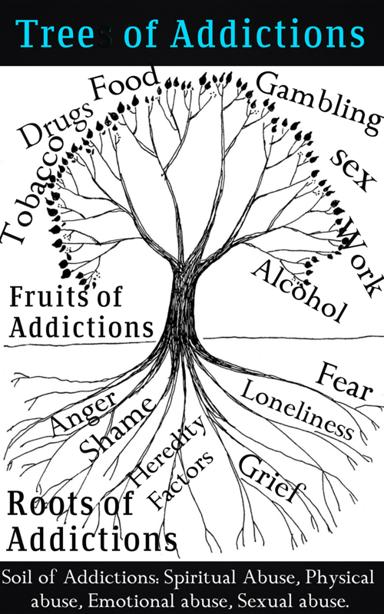What is the purpose of showing the Tree of Addictions in this way? The Tree of Addictions image serves as a compelling metaphorical visualization aimed at illustrating the multifaceted nature of addiction. The intent is to communicate that addictions are not isolated behaviors but are interwoven with emotional consequences (the fruits), have deeper psychological or genetic origins (the roots), and are often fostered by damaging environments or traumatic experiences (the soil). This tree structure eloquently demonstrates that addressing addiction is not merely about curtailing the addictive behavior itself, but requires a comprehensive approach that includes understanding and healing from the emotional pain, uncovering and managing the underlying predispositions, and overcoming the harmful experiences that may have nurtured the addictive tendencies. 